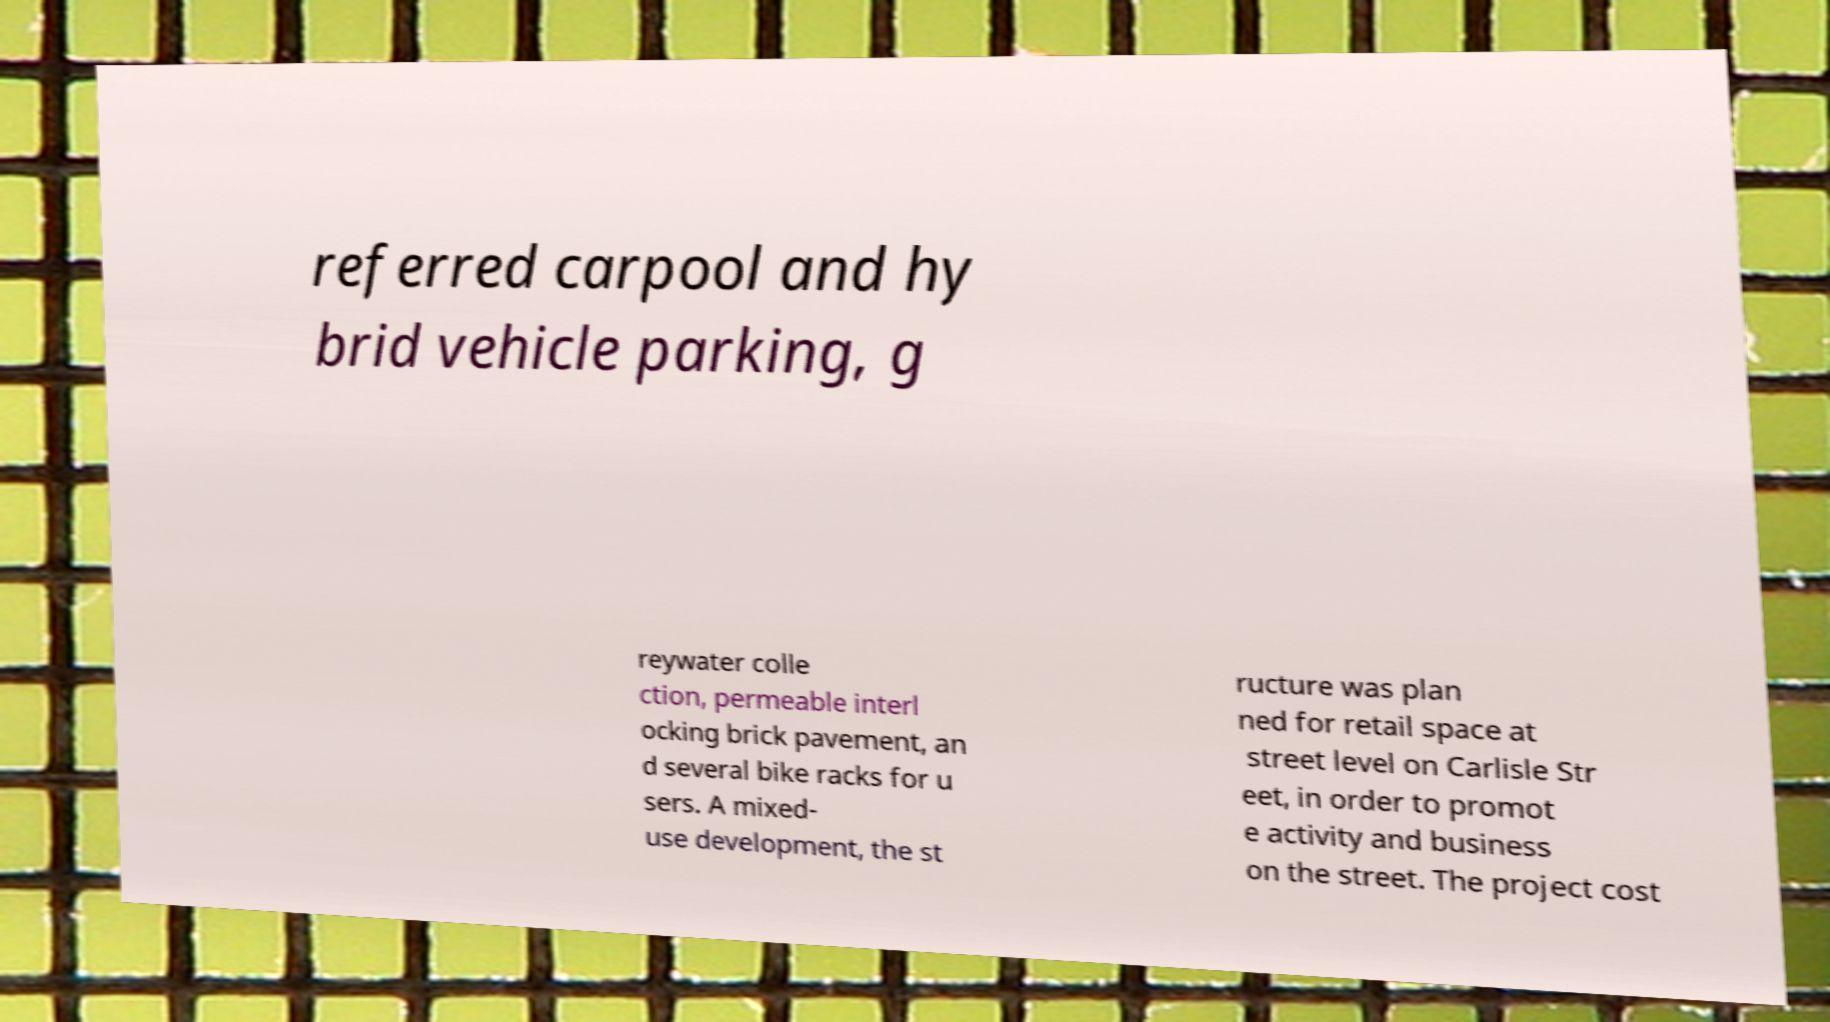Can you read and provide the text displayed in the image?This photo seems to have some interesting text. Can you extract and type it out for me? referred carpool and hy brid vehicle parking, g reywater colle ction, permeable interl ocking brick pavement, an d several bike racks for u sers. A mixed- use development, the st ructure was plan ned for retail space at street level on Carlisle Str eet, in order to promot e activity and business on the street. The project cost 